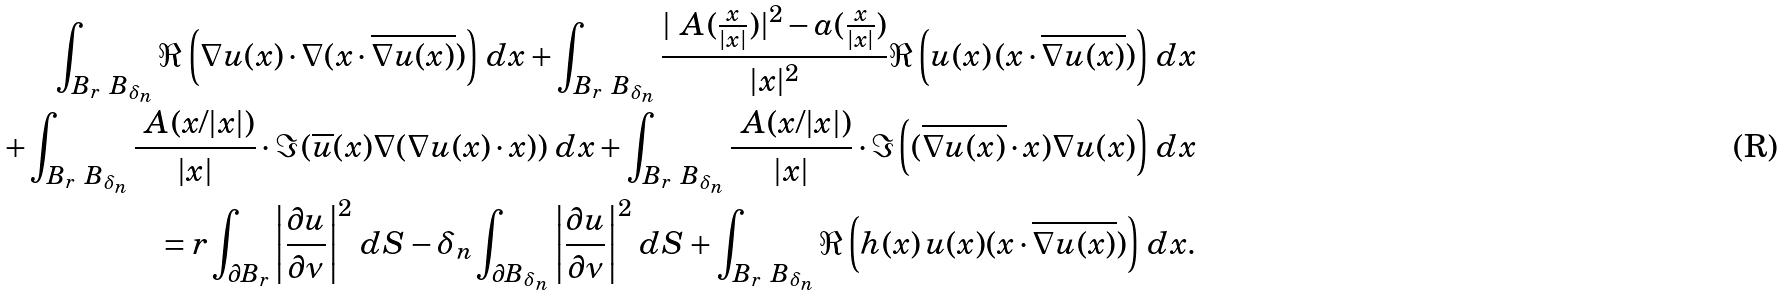<formula> <loc_0><loc_0><loc_500><loc_500>\int _ { B _ { r } \ B _ { \delta _ { n } } } \Re \left ( \nabla u ( x ) \cdot \nabla ( x \cdot \overline { \nabla u ( x ) } ) \right ) \, d x + \int _ { B _ { r } \ B _ { \delta _ { n } } } \frac { | \ A ( \frac { x } { | x | } ) | ^ { 2 } - a ( \frac { x } { | x | } ) } { | x | ^ { 2 } } \Re \left ( u ( x ) \, ( x \cdot \overline { \nabla u ( x ) } ) \right ) \, d x \\ + \int _ { B _ { r } \ B _ { \delta _ { n } } } \frac { \ A ( x / | x | ) } { | x | } \cdot \Im \left ( \overline { u } ( x ) \nabla ( \nabla u ( x ) \cdot x ) \right ) \, d x + \int _ { B _ { r } \ B _ { \delta _ { n } } } \frac { \ A ( x / | x | ) } { | x | } \cdot \Im \left ( ( \overline { \nabla u ( x ) } \cdot x ) \nabla u ( x ) \right ) \, d x \\ = r \int _ { \partial B _ { r } } \left | \frac { \partial u } { \partial \nu } \right | ^ { 2 } \, d S - { \delta _ { n } } \int _ { \partial B _ { \delta _ { n } } } \left | \frac { \partial u } { \partial \nu } \right | ^ { 2 } \, d S + \int _ { B _ { r } \ B _ { \delta _ { n } } } \Re \left ( h ( x ) \, u ( x ) ( x \cdot \overline { \nabla u ( x ) } ) \right ) \, d x .</formula> 